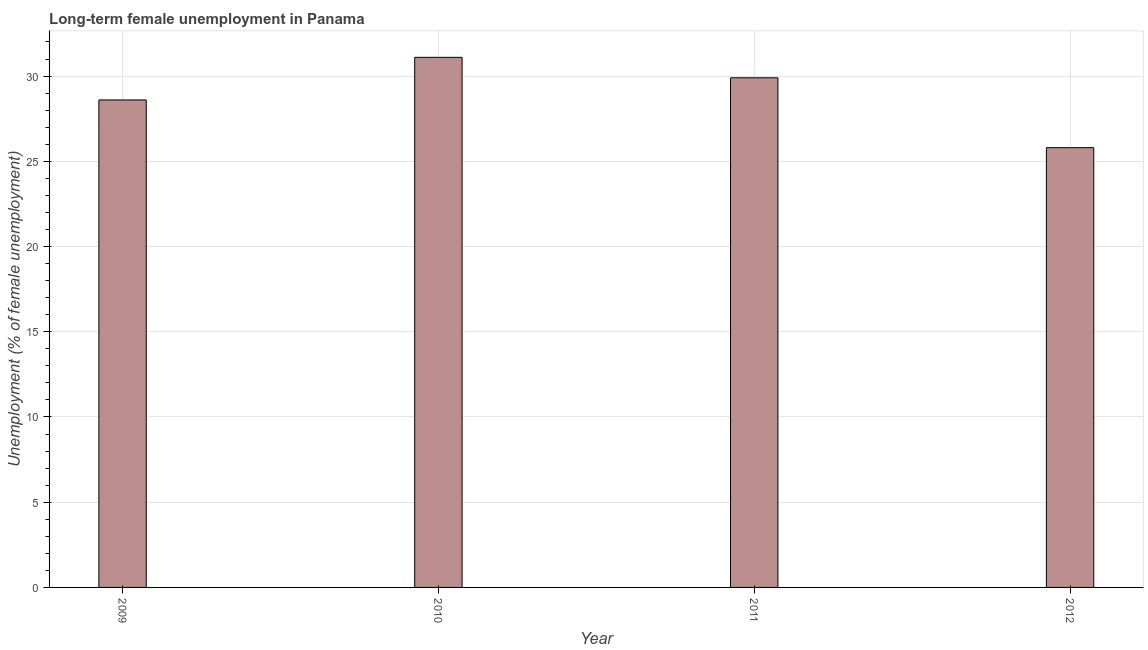Does the graph contain grids?
Offer a terse response. Yes. What is the title of the graph?
Offer a very short reply. Long-term female unemployment in Panama. What is the label or title of the X-axis?
Keep it short and to the point. Year. What is the label or title of the Y-axis?
Ensure brevity in your answer.  Unemployment (% of female unemployment). What is the long-term female unemployment in 2010?
Ensure brevity in your answer.  31.1. Across all years, what is the maximum long-term female unemployment?
Provide a short and direct response. 31.1. Across all years, what is the minimum long-term female unemployment?
Provide a succinct answer. 25.8. In which year was the long-term female unemployment minimum?
Keep it short and to the point. 2012. What is the sum of the long-term female unemployment?
Ensure brevity in your answer.  115.4. What is the average long-term female unemployment per year?
Provide a short and direct response. 28.85. What is the median long-term female unemployment?
Make the answer very short. 29.25. What is the ratio of the long-term female unemployment in 2010 to that in 2012?
Provide a short and direct response. 1.21. What is the difference between the highest and the second highest long-term female unemployment?
Keep it short and to the point. 1.2. In how many years, is the long-term female unemployment greater than the average long-term female unemployment taken over all years?
Your response must be concise. 2. What is the difference between two consecutive major ticks on the Y-axis?
Offer a terse response. 5. What is the Unemployment (% of female unemployment) in 2009?
Your response must be concise. 28.6. What is the Unemployment (% of female unemployment) in 2010?
Make the answer very short. 31.1. What is the Unemployment (% of female unemployment) of 2011?
Keep it short and to the point. 29.9. What is the Unemployment (% of female unemployment) in 2012?
Your answer should be very brief. 25.8. What is the difference between the Unemployment (% of female unemployment) in 2009 and 2010?
Provide a short and direct response. -2.5. What is the difference between the Unemployment (% of female unemployment) in 2009 and 2011?
Make the answer very short. -1.3. What is the difference between the Unemployment (% of female unemployment) in 2011 and 2012?
Keep it short and to the point. 4.1. What is the ratio of the Unemployment (% of female unemployment) in 2009 to that in 2010?
Your response must be concise. 0.92. What is the ratio of the Unemployment (% of female unemployment) in 2009 to that in 2011?
Give a very brief answer. 0.96. What is the ratio of the Unemployment (% of female unemployment) in 2009 to that in 2012?
Provide a short and direct response. 1.11. What is the ratio of the Unemployment (% of female unemployment) in 2010 to that in 2012?
Your response must be concise. 1.21. What is the ratio of the Unemployment (% of female unemployment) in 2011 to that in 2012?
Your answer should be very brief. 1.16. 